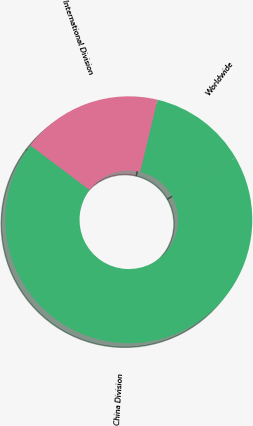Convert chart. <chart><loc_0><loc_0><loc_500><loc_500><pie_chart><fcel>International Division<fcel>China Division<fcel>Worldwide<nl><fcel>18.45%<fcel>68.67%<fcel>12.88%<nl></chart> 